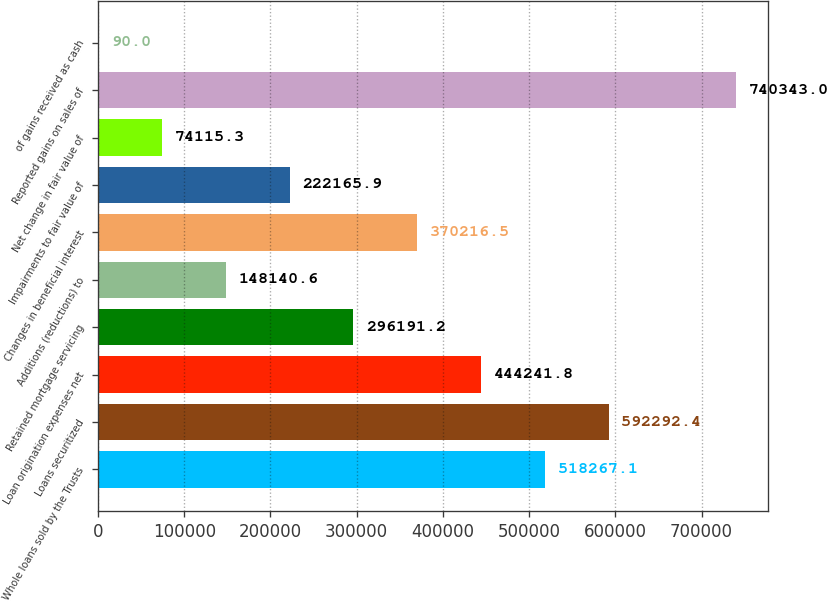Convert chart to OTSL. <chart><loc_0><loc_0><loc_500><loc_500><bar_chart><fcel>Whole loans sold by the Trusts<fcel>Loans securitized<fcel>Loan origination expenses net<fcel>Retained mortgage servicing<fcel>Additions (reductions) to<fcel>Changes in beneficial interest<fcel>Impairments to fair value of<fcel>Net change in fair value of<fcel>Reported gains on sales of<fcel>of gains received as cash<nl><fcel>518267<fcel>592292<fcel>444242<fcel>296191<fcel>148141<fcel>370216<fcel>222166<fcel>74115.3<fcel>740343<fcel>90<nl></chart> 